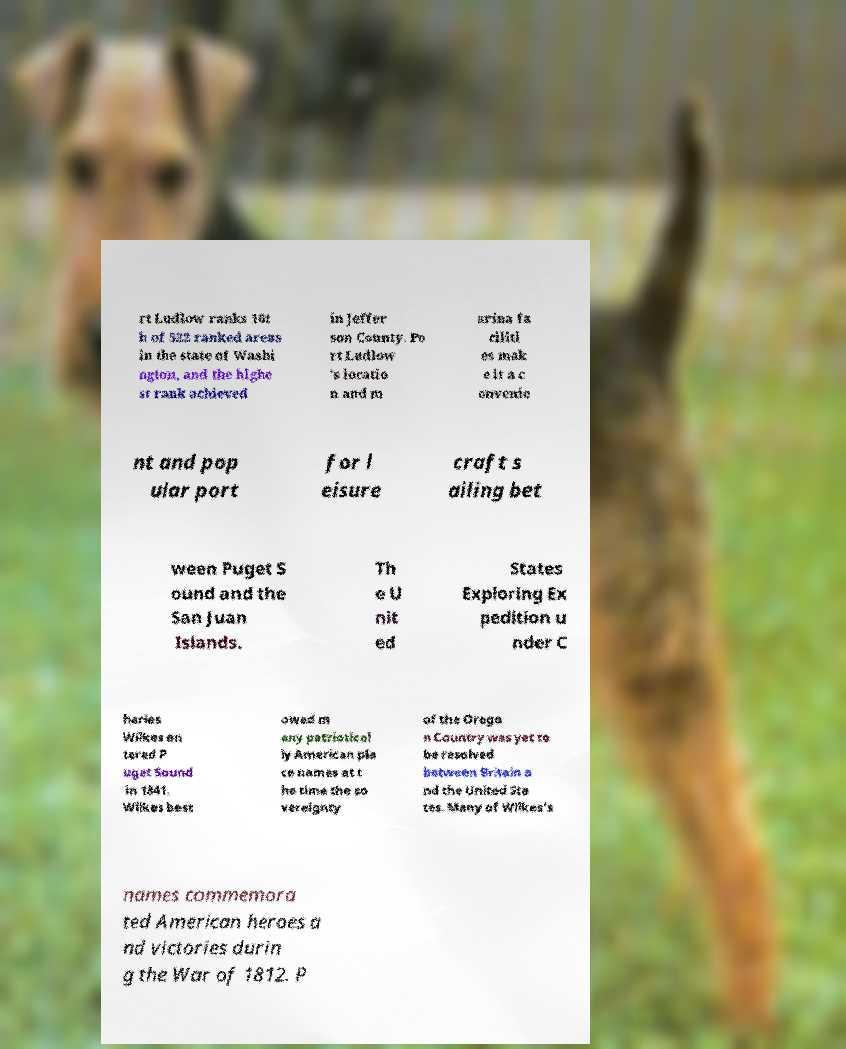What messages or text are displayed in this image? I need them in a readable, typed format. rt Ludlow ranks 16t h of 522 ranked areas in the state of Washi ngton, and the highe st rank achieved in Jeffer son County. Po rt Ludlow 's locatio n and m arina fa ciliti es mak e it a c onvenie nt and pop ular port for l eisure craft s ailing bet ween Puget S ound and the San Juan Islands. Th e U nit ed States Exploring Ex pedition u nder C harles Wilkes en tered P uget Sound in 1841. Wilkes best owed m any patriotical ly American pla ce names at t he time the so vereignty of the Orego n Country was yet to be resolved between Britain a nd the United Sta tes. Many of Wilkes's names commemora ted American heroes a nd victories durin g the War of 1812. P 